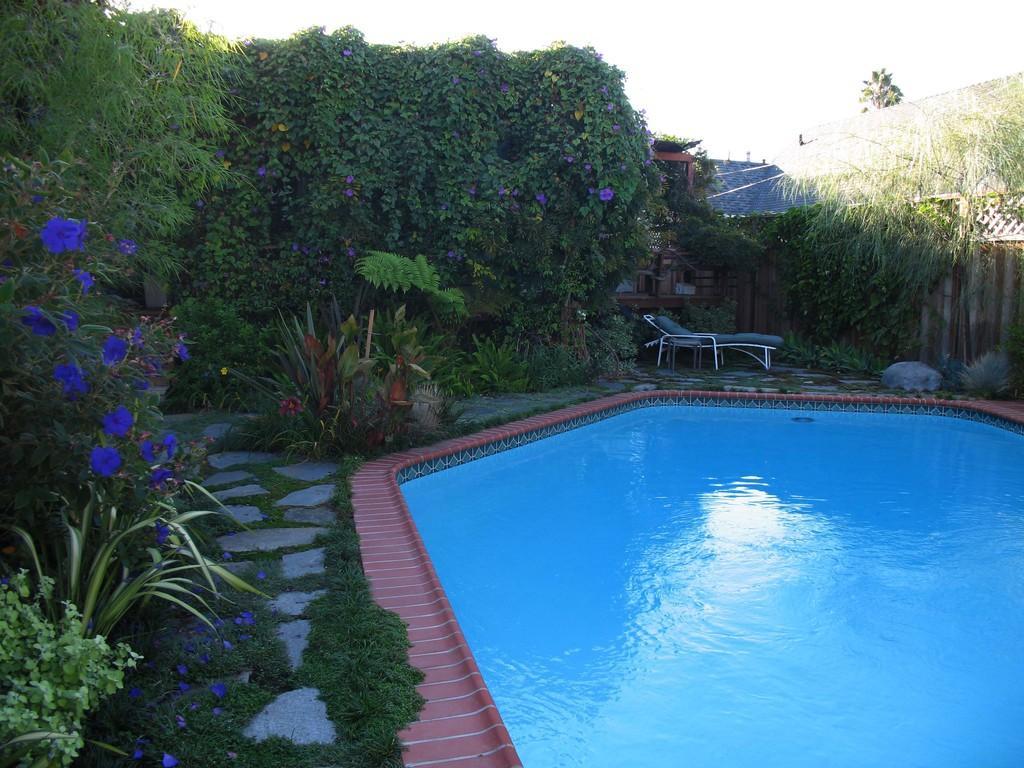Describe this image in one or two sentences. In the image we can see there is a swimming pool and there are grass on the ground. There are flowers on the plants and there are trees. There is a chair kept on the ground and there are roofs of the buildings. There is a clear sky. 